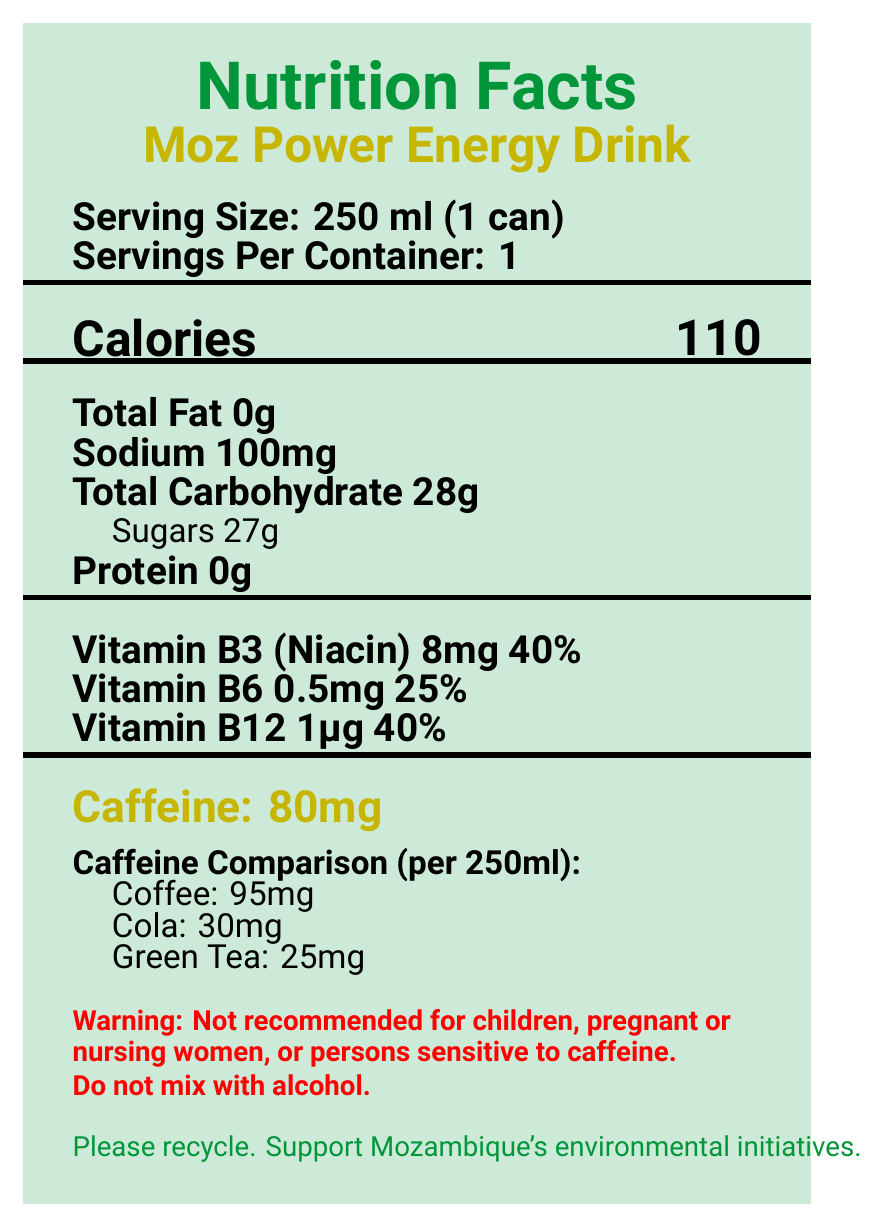what is the serving size for Moz Power Energy Drink? The serving size is directly stated as 250 ml or 1 can in the document.
Answer: 250 ml (1 can) how many calories are in a serving of this energy drink? The document clearly lists that there are 110 calories per serving.
Answer: 110 how much caffeine does one can of Moz Power Energy Drink contain? This information is highlighted under the "Caffeine" section in the document.
Answer: 80mg what type of facility produces this energy drink? This is mentioned in the allergen information section.
Answer: A facility that processes milk and soy list three vitamins found in Moz Power Energy Drink. These vitamins are listed in the vitamins and minerals section of the document.
Answer: Vitamin B3 (Niacin), Vitamin B6, Vitamin B12 how does the caffeine content of Moz Power compare to coffee, cola, and green tea per 250ml? The document provides a comparison: Moz Power (80mg) vs. coffee (95mg), cola (30mg), and green tea (25mg).
Answer: Lower than coffee, higher than cola and green tea what warning is associated with the consumption of this energy drink? A. Not for children B. Not for people with diabetes C. Do not exceed recommended dose D. Do not mix with alcohol The document states that the drink is not recommended for children and should not be mixed with alcohol.
Answer: A and D which of the following contains the most sugar per 250 ml serving? A. Moz Power Energy Drink B. Coffee C. Cola The document lists Moz Power as having 27g of sugars, while coffee and cola do not list sugar content here.
Answer: A. Moz Power Energy Drink is it recommended for pregnant or nursing women to consume this energy drink? The warning section explicitly states that it is not recommended for pregnant or nursing women.
Answer: No summarize the main nutritional information and warnings about Moz Power Energy Drink. This includes key nutritional data, warnings, and a note on its popularity among students.
Answer: Moz Power Energy Drink is a caffeinated beverage containing 110 calories, 80mg of caffeine, and various vitamins like B3, B6, and B12. It's produced in a facility processing milk and soy. Not recommended for children, pregnant or nursing women, or persons sensitive to caffeine. Do not mix with alcohol. Popular among university students during late-night study sessions. what is the sodium content per serving? The sodium content per serving is listed as 100mg in the document.
Answer: 100mg where is this energy drink produced? The origin section of the document specifies it is made in Maputo, Mozambique.
Answer: Maputo, Mozambique what is the protein content in a serving of Moz Power Energy Drink? The document states the protein content as 0g per serving.
Answer: 0g how much Vitamin B6 is in a serving, and what percentage of the daily value does this represent? The document lists 0.5mg of Vitamin B6, representing 25% of the daily value.
Answer: 0.5mg, 25% which company manufactures Moz Power Energy Drink? This information is provided under the manufacturer section in the document.
Answer: Mozambique Beverages Ltd. how does the number of calories in Moz Power compare to a typical soda? The document does not provide calorie information for sodas, so a comparison cannot be made.
Answer: Cannot be determined what environmental suggestion does the document make? The document suggests recycling to support Mozambique's environmental initiatives.
Answer: Please recycle 